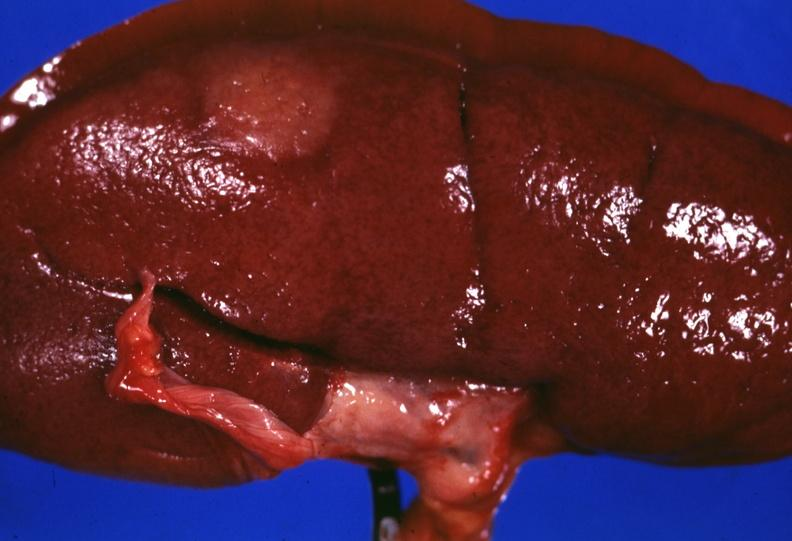what does this image show?
Answer the question using a single word or phrase. Surface lesion capsule stripped unusual 